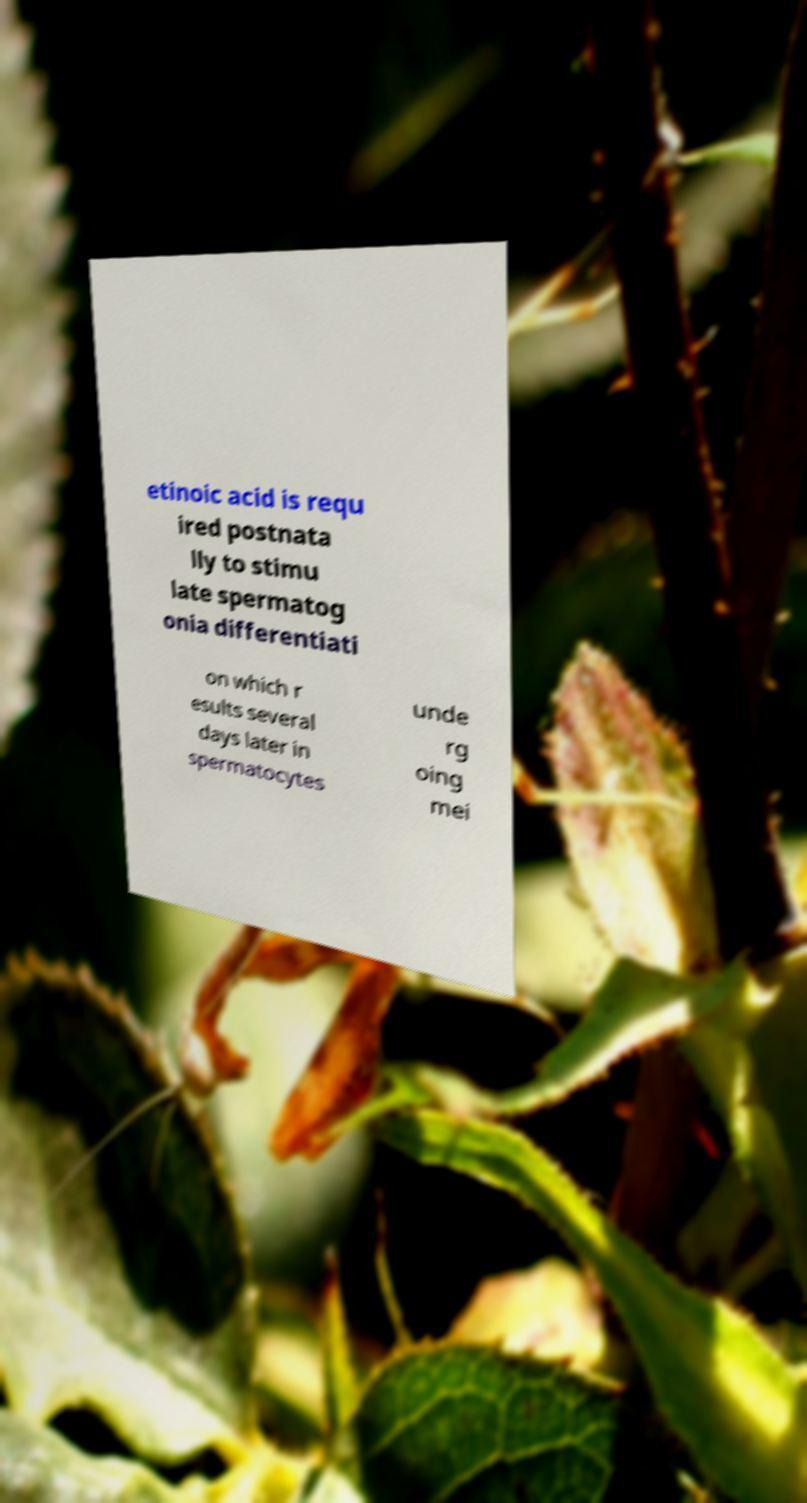I need the written content from this picture converted into text. Can you do that? etinoic acid is requ ired postnata lly to stimu late spermatog onia differentiati on which r esults several days later in spermatocytes unde rg oing mei 